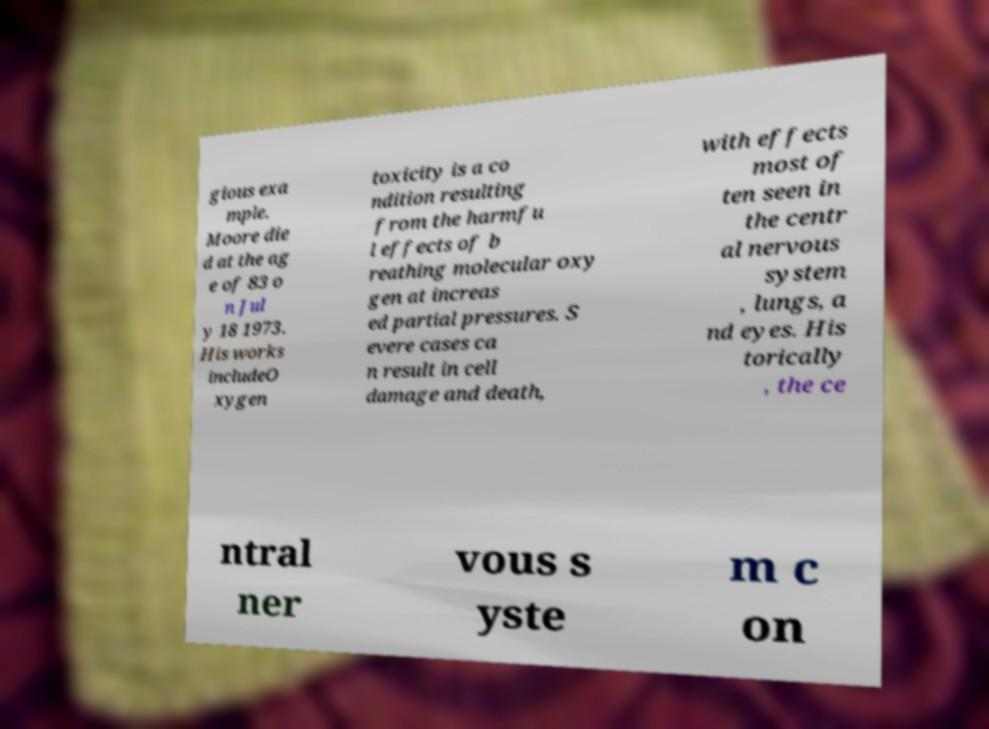Please identify and transcribe the text found in this image. gious exa mple. Moore die d at the ag e of 83 o n Jul y 18 1973. His works includeO xygen toxicity is a co ndition resulting from the harmfu l effects of b reathing molecular oxy gen at increas ed partial pressures. S evere cases ca n result in cell damage and death, with effects most of ten seen in the centr al nervous system , lungs, a nd eyes. His torically , the ce ntral ner vous s yste m c on 